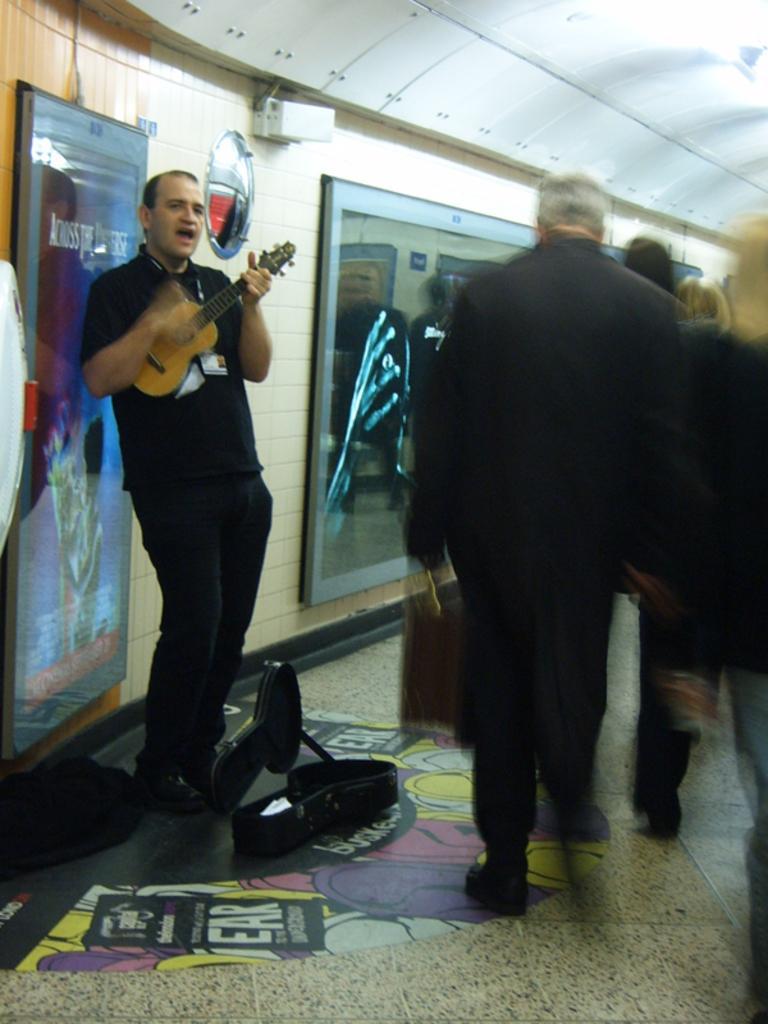Describe this image in one or two sentences. In this image there are group of persons walking at the right side of the image and at the middle of the image there is a person wearing black color dress playing guitar. 